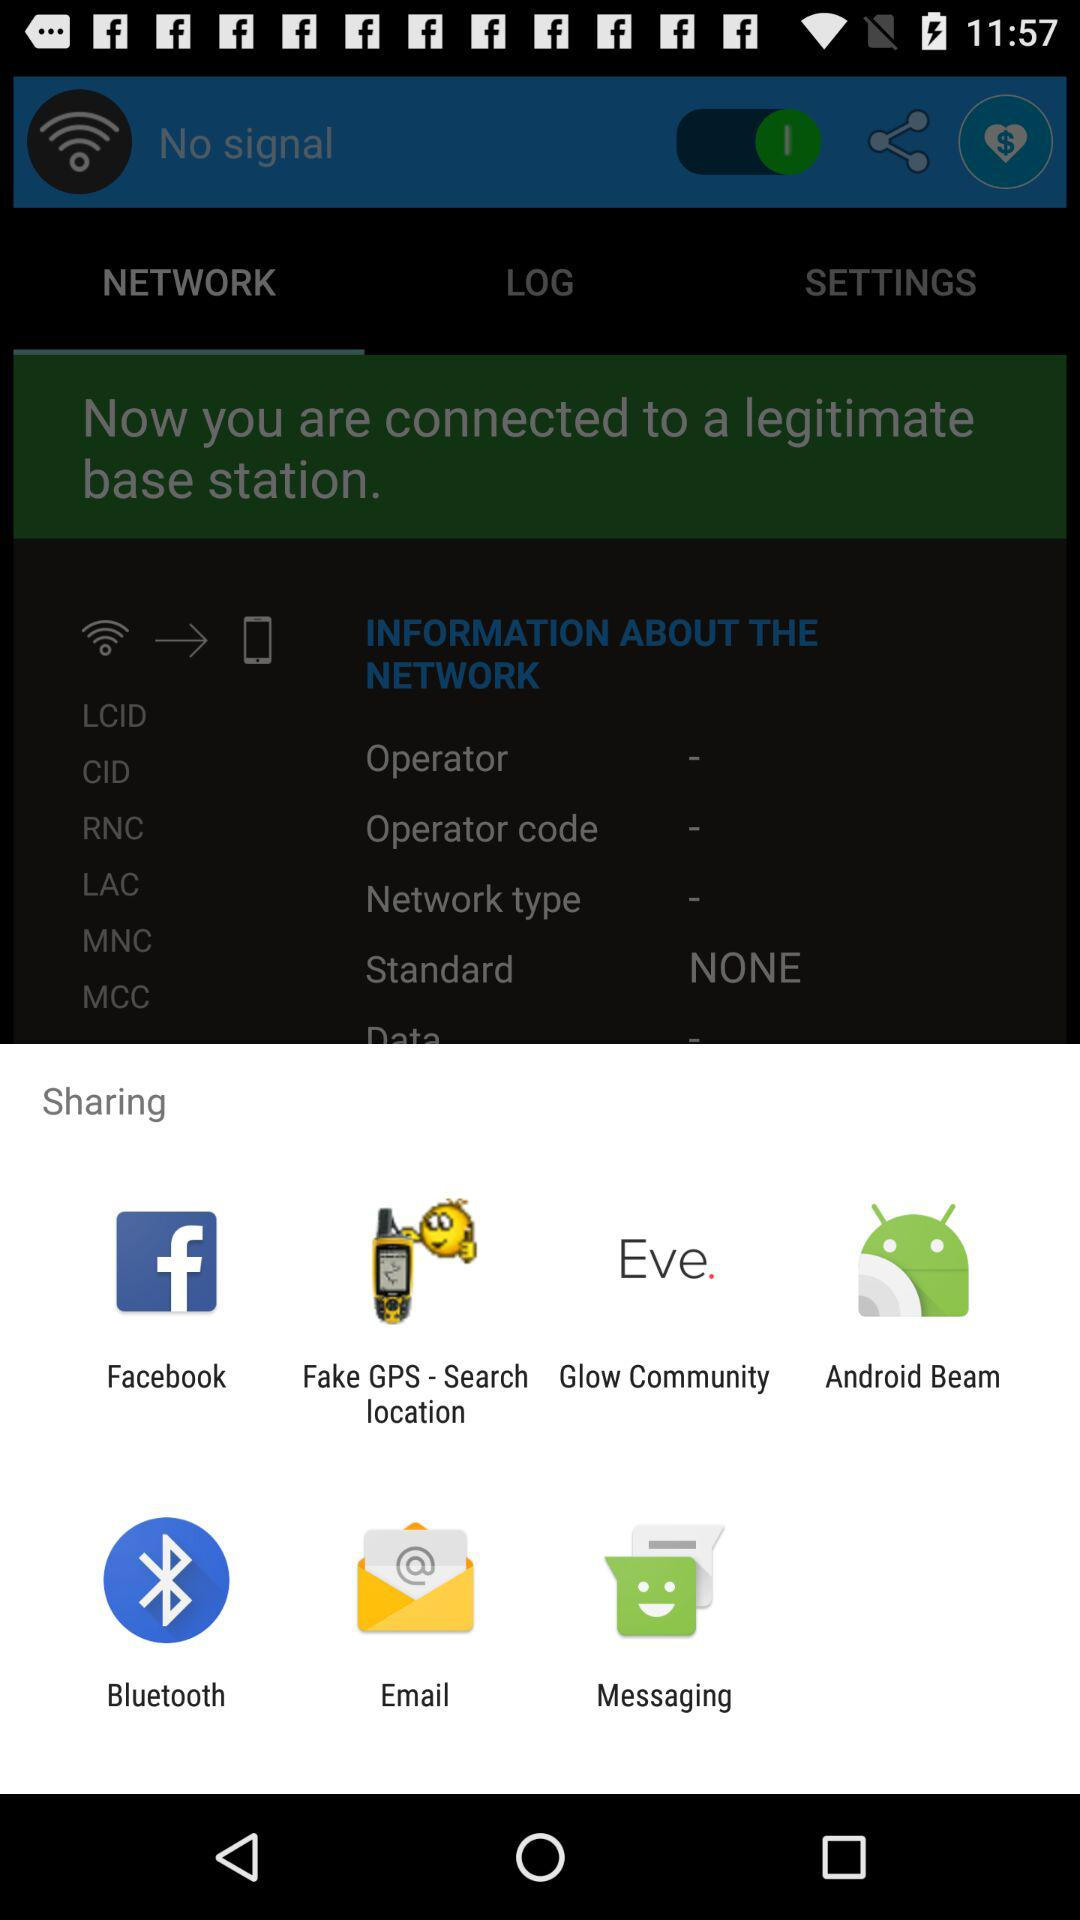What are the sharing options? The sharing options are "Facebook", "Fake GPS - Search location", "Glow Community", "Android Beam", "Bluetooth", "Email" and "Messaging". 